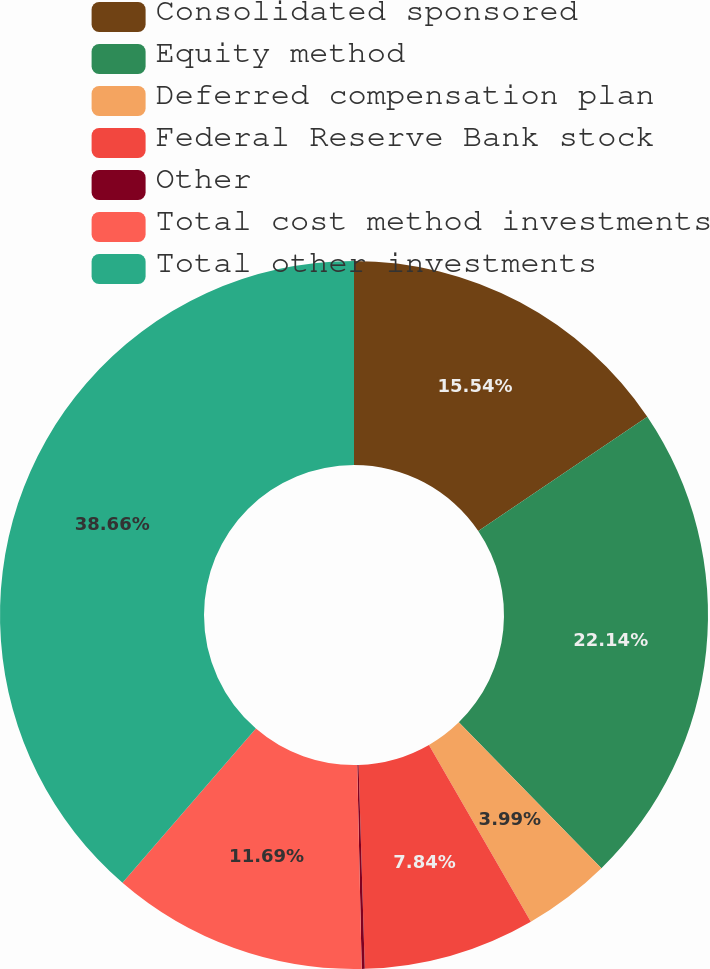<chart> <loc_0><loc_0><loc_500><loc_500><pie_chart><fcel>Consolidated sponsored<fcel>Equity method<fcel>Deferred compensation plan<fcel>Federal Reserve Bank stock<fcel>Other<fcel>Total cost method investments<fcel>Total other investments<nl><fcel>15.54%<fcel>22.14%<fcel>3.99%<fcel>7.84%<fcel>0.14%<fcel>11.69%<fcel>38.65%<nl></chart> 